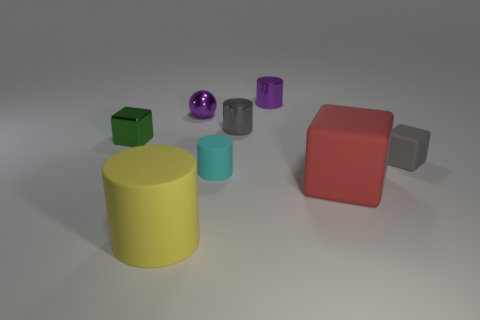Add 1 big green objects. How many objects exist? 9 Subtract all cubes. How many objects are left? 5 Add 5 small blue metallic cubes. How many small blue metallic cubes exist? 5 Subtract 1 green cubes. How many objects are left? 7 Subtract all tiny green metallic cubes. Subtract all small gray matte cubes. How many objects are left? 6 Add 8 small cyan matte cylinders. How many small cyan matte cylinders are left? 9 